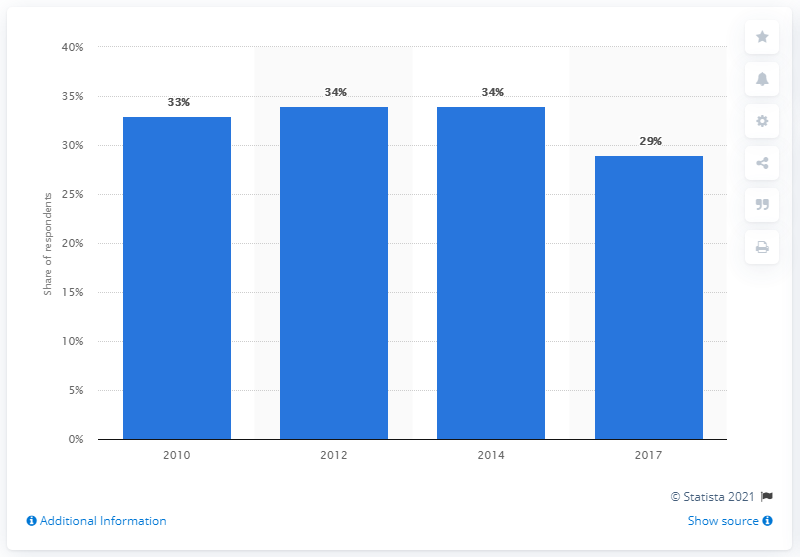Point out several critical features in this image. In 2017, about 29% of consumers visited a pub on a weekly basis. 